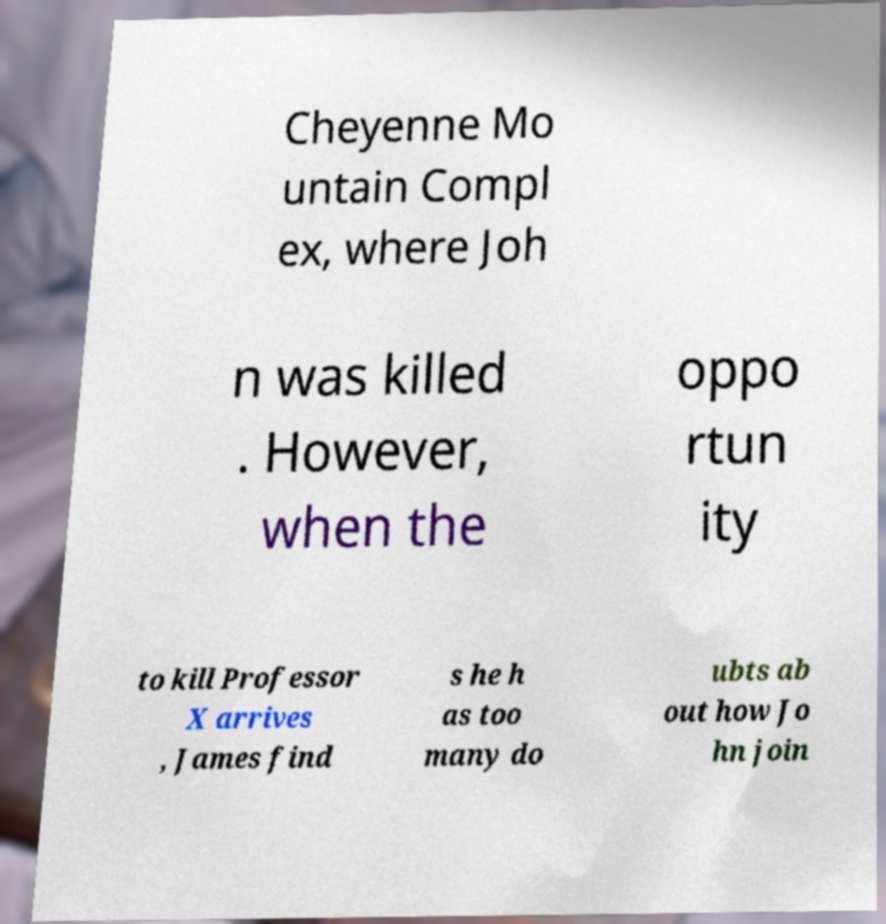Please identify and transcribe the text found in this image. Cheyenne Mo untain Compl ex, where Joh n was killed . However, when the oppo rtun ity to kill Professor X arrives , James find s he h as too many do ubts ab out how Jo hn join 